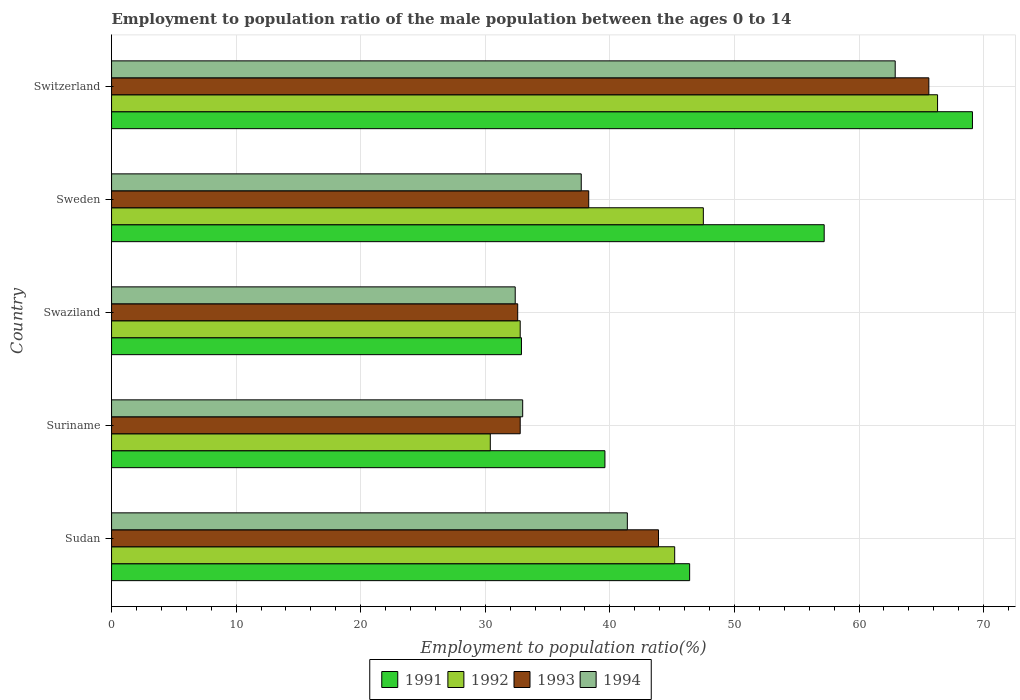How many groups of bars are there?
Keep it short and to the point. 5. Are the number of bars on each tick of the Y-axis equal?
Your response must be concise. Yes. What is the label of the 5th group of bars from the top?
Your answer should be very brief. Sudan. What is the employment to population ratio in 1991 in Swaziland?
Make the answer very short. 32.9. Across all countries, what is the maximum employment to population ratio in 1994?
Your answer should be compact. 62.9. Across all countries, what is the minimum employment to population ratio in 1992?
Your answer should be very brief. 30.4. In which country was the employment to population ratio in 1991 maximum?
Offer a terse response. Switzerland. In which country was the employment to population ratio in 1992 minimum?
Make the answer very short. Suriname. What is the total employment to population ratio in 1993 in the graph?
Offer a very short reply. 213.2. What is the difference between the employment to population ratio in 1994 in Sweden and that in Switzerland?
Give a very brief answer. -25.2. What is the difference between the employment to population ratio in 1993 in Suriname and the employment to population ratio in 1992 in Sweden?
Provide a short and direct response. -14.7. What is the average employment to population ratio in 1993 per country?
Your answer should be very brief. 42.64. What is the difference between the employment to population ratio in 1992 and employment to population ratio in 1991 in Sudan?
Your answer should be very brief. -1.2. What is the ratio of the employment to population ratio in 1991 in Sudan to that in Sweden?
Offer a very short reply. 0.81. Is the employment to population ratio in 1992 in Sudan less than that in Suriname?
Offer a very short reply. No. Is the difference between the employment to population ratio in 1992 in Suriname and Swaziland greater than the difference between the employment to population ratio in 1991 in Suriname and Swaziland?
Your answer should be compact. No. What is the difference between the highest and the second highest employment to population ratio in 1991?
Provide a succinct answer. 11.9. What is the difference between the highest and the lowest employment to population ratio in 1992?
Offer a very short reply. 35.9. Is it the case that in every country, the sum of the employment to population ratio in 1991 and employment to population ratio in 1994 is greater than the sum of employment to population ratio in 1992 and employment to population ratio in 1993?
Ensure brevity in your answer.  No. What does the 4th bar from the top in Swaziland represents?
Offer a very short reply. 1991. Are all the bars in the graph horizontal?
Your response must be concise. Yes. How many countries are there in the graph?
Provide a succinct answer. 5. Are the values on the major ticks of X-axis written in scientific E-notation?
Make the answer very short. No. Does the graph contain any zero values?
Offer a terse response. No. Does the graph contain grids?
Keep it short and to the point. Yes. How many legend labels are there?
Your response must be concise. 4. How are the legend labels stacked?
Offer a terse response. Horizontal. What is the title of the graph?
Your response must be concise. Employment to population ratio of the male population between the ages 0 to 14. Does "2002" appear as one of the legend labels in the graph?
Make the answer very short. No. What is the Employment to population ratio(%) in 1991 in Sudan?
Give a very brief answer. 46.4. What is the Employment to population ratio(%) in 1992 in Sudan?
Offer a very short reply. 45.2. What is the Employment to population ratio(%) of 1993 in Sudan?
Give a very brief answer. 43.9. What is the Employment to population ratio(%) of 1994 in Sudan?
Provide a succinct answer. 41.4. What is the Employment to population ratio(%) in 1991 in Suriname?
Keep it short and to the point. 39.6. What is the Employment to population ratio(%) of 1992 in Suriname?
Your answer should be very brief. 30.4. What is the Employment to population ratio(%) in 1993 in Suriname?
Your response must be concise. 32.8. What is the Employment to population ratio(%) in 1991 in Swaziland?
Give a very brief answer. 32.9. What is the Employment to population ratio(%) in 1992 in Swaziland?
Your answer should be very brief. 32.8. What is the Employment to population ratio(%) of 1993 in Swaziland?
Your response must be concise. 32.6. What is the Employment to population ratio(%) of 1994 in Swaziland?
Give a very brief answer. 32.4. What is the Employment to population ratio(%) in 1991 in Sweden?
Provide a succinct answer. 57.2. What is the Employment to population ratio(%) in 1992 in Sweden?
Your answer should be compact. 47.5. What is the Employment to population ratio(%) in 1993 in Sweden?
Make the answer very short. 38.3. What is the Employment to population ratio(%) in 1994 in Sweden?
Provide a succinct answer. 37.7. What is the Employment to population ratio(%) in 1991 in Switzerland?
Your answer should be compact. 69.1. What is the Employment to population ratio(%) in 1992 in Switzerland?
Ensure brevity in your answer.  66.3. What is the Employment to population ratio(%) of 1993 in Switzerland?
Your answer should be compact. 65.6. What is the Employment to population ratio(%) of 1994 in Switzerland?
Your response must be concise. 62.9. Across all countries, what is the maximum Employment to population ratio(%) in 1991?
Your answer should be very brief. 69.1. Across all countries, what is the maximum Employment to population ratio(%) of 1992?
Your response must be concise. 66.3. Across all countries, what is the maximum Employment to population ratio(%) in 1993?
Provide a succinct answer. 65.6. Across all countries, what is the maximum Employment to population ratio(%) of 1994?
Keep it short and to the point. 62.9. Across all countries, what is the minimum Employment to population ratio(%) of 1991?
Make the answer very short. 32.9. Across all countries, what is the minimum Employment to population ratio(%) of 1992?
Provide a short and direct response. 30.4. Across all countries, what is the minimum Employment to population ratio(%) in 1993?
Your answer should be very brief. 32.6. Across all countries, what is the minimum Employment to population ratio(%) in 1994?
Offer a terse response. 32.4. What is the total Employment to population ratio(%) of 1991 in the graph?
Ensure brevity in your answer.  245.2. What is the total Employment to population ratio(%) in 1992 in the graph?
Provide a succinct answer. 222.2. What is the total Employment to population ratio(%) in 1993 in the graph?
Give a very brief answer. 213.2. What is the total Employment to population ratio(%) in 1994 in the graph?
Offer a very short reply. 207.4. What is the difference between the Employment to population ratio(%) in 1991 in Sudan and that in Sweden?
Ensure brevity in your answer.  -10.8. What is the difference between the Employment to population ratio(%) in 1991 in Sudan and that in Switzerland?
Provide a succinct answer. -22.7. What is the difference between the Employment to population ratio(%) in 1992 in Sudan and that in Switzerland?
Your answer should be compact. -21.1. What is the difference between the Employment to population ratio(%) in 1993 in Sudan and that in Switzerland?
Ensure brevity in your answer.  -21.7. What is the difference between the Employment to population ratio(%) in 1994 in Sudan and that in Switzerland?
Offer a terse response. -21.5. What is the difference between the Employment to population ratio(%) of 1992 in Suriname and that in Swaziland?
Offer a very short reply. -2.4. What is the difference between the Employment to population ratio(%) in 1993 in Suriname and that in Swaziland?
Your answer should be very brief. 0.2. What is the difference between the Employment to population ratio(%) of 1991 in Suriname and that in Sweden?
Offer a terse response. -17.6. What is the difference between the Employment to population ratio(%) in 1992 in Suriname and that in Sweden?
Provide a succinct answer. -17.1. What is the difference between the Employment to population ratio(%) in 1993 in Suriname and that in Sweden?
Your response must be concise. -5.5. What is the difference between the Employment to population ratio(%) of 1994 in Suriname and that in Sweden?
Ensure brevity in your answer.  -4.7. What is the difference between the Employment to population ratio(%) in 1991 in Suriname and that in Switzerland?
Provide a short and direct response. -29.5. What is the difference between the Employment to population ratio(%) in 1992 in Suriname and that in Switzerland?
Ensure brevity in your answer.  -35.9. What is the difference between the Employment to population ratio(%) in 1993 in Suriname and that in Switzerland?
Offer a very short reply. -32.8. What is the difference between the Employment to population ratio(%) of 1994 in Suriname and that in Switzerland?
Offer a very short reply. -29.9. What is the difference between the Employment to population ratio(%) in 1991 in Swaziland and that in Sweden?
Your answer should be very brief. -24.3. What is the difference between the Employment to population ratio(%) in 1992 in Swaziland and that in Sweden?
Provide a short and direct response. -14.7. What is the difference between the Employment to population ratio(%) in 1993 in Swaziland and that in Sweden?
Your answer should be compact. -5.7. What is the difference between the Employment to population ratio(%) in 1991 in Swaziland and that in Switzerland?
Make the answer very short. -36.2. What is the difference between the Employment to population ratio(%) in 1992 in Swaziland and that in Switzerland?
Make the answer very short. -33.5. What is the difference between the Employment to population ratio(%) in 1993 in Swaziland and that in Switzerland?
Offer a very short reply. -33. What is the difference between the Employment to population ratio(%) of 1994 in Swaziland and that in Switzerland?
Offer a terse response. -30.5. What is the difference between the Employment to population ratio(%) of 1991 in Sweden and that in Switzerland?
Offer a very short reply. -11.9. What is the difference between the Employment to population ratio(%) in 1992 in Sweden and that in Switzerland?
Your response must be concise. -18.8. What is the difference between the Employment to population ratio(%) of 1993 in Sweden and that in Switzerland?
Provide a short and direct response. -27.3. What is the difference between the Employment to population ratio(%) in 1994 in Sweden and that in Switzerland?
Your response must be concise. -25.2. What is the difference between the Employment to population ratio(%) in 1991 in Sudan and the Employment to population ratio(%) in 1992 in Suriname?
Your answer should be very brief. 16. What is the difference between the Employment to population ratio(%) of 1991 in Sudan and the Employment to population ratio(%) of 1993 in Suriname?
Make the answer very short. 13.6. What is the difference between the Employment to population ratio(%) in 1992 in Sudan and the Employment to population ratio(%) in 1993 in Suriname?
Your answer should be compact. 12.4. What is the difference between the Employment to population ratio(%) in 1992 in Sudan and the Employment to population ratio(%) in 1994 in Suriname?
Offer a terse response. 12.2. What is the difference between the Employment to population ratio(%) of 1993 in Sudan and the Employment to population ratio(%) of 1994 in Suriname?
Provide a succinct answer. 10.9. What is the difference between the Employment to population ratio(%) in 1991 in Sudan and the Employment to population ratio(%) in 1993 in Swaziland?
Offer a very short reply. 13.8. What is the difference between the Employment to population ratio(%) in 1991 in Sudan and the Employment to population ratio(%) in 1992 in Sweden?
Give a very brief answer. -1.1. What is the difference between the Employment to population ratio(%) in 1991 in Sudan and the Employment to population ratio(%) in 1994 in Sweden?
Provide a short and direct response. 8.7. What is the difference between the Employment to population ratio(%) in 1992 in Sudan and the Employment to population ratio(%) in 1994 in Sweden?
Provide a succinct answer. 7.5. What is the difference between the Employment to population ratio(%) of 1993 in Sudan and the Employment to population ratio(%) of 1994 in Sweden?
Offer a very short reply. 6.2. What is the difference between the Employment to population ratio(%) in 1991 in Sudan and the Employment to population ratio(%) in 1992 in Switzerland?
Provide a succinct answer. -19.9. What is the difference between the Employment to population ratio(%) in 1991 in Sudan and the Employment to population ratio(%) in 1993 in Switzerland?
Your answer should be compact. -19.2. What is the difference between the Employment to population ratio(%) in 1991 in Sudan and the Employment to population ratio(%) in 1994 in Switzerland?
Give a very brief answer. -16.5. What is the difference between the Employment to population ratio(%) in 1992 in Sudan and the Employment to population ratio(%) in 1993 in Switzerland?
Your answer should be compact. -20.4. What is the difference between the Employment to population ratio(%) in 1992 in Sudan and the Employment to population ratio(%) in 1994 in Switzerland?
Provide a short and direct response. -17.7. What is the difference between the Employment to population ratio(%) of 1993 in Sudan and the Employment to population ratio(%) of 1994 in Switzerland?
Make the answer very short. -19. What is the difference between the Employment to population ratio(%) of 1991 in Suriname and the Employment to population ratio(%) of 1992 in Swaziland?
Your answer should be compact. 6.8. What is the difference between the Employment to population ratio(%) in 1991 in Suriname and the Employment to population ratio(%) in 1993 in Swaziland?
Offer a terse response. 7. What is the difference between the Employment to population ratio(%) in 1992 in Suriname and the Employment to population ratio(%) in 1993 in Swaziland?
Your answer should be very brief. -2.2. What is the difference between the Employment to population ratio(%) of 1991 in Suriname and the Employment to population ratio(%) of 1994 in Sweden?
Offer a very short reply. 1.9. What is the difference between the Employment to population ratio(%) in 1992 in Suriname and the Employment to population ratio(%) in 1993 in Sweden?
Provide a short and direct response. -7.9. What is the difference between the Employment to population ratio(%) in 1992 in Suriname and the Employment to population ratio(%) in 1994 in Sweden?
Provide a succinct answer. -7.3. What is the difference between the Employment to population ratio(%) in 1993 in Suriname and the Employment to population ratio(%) in 1994 in Sweden?
Give a very brief answer. -4.9. What is the difference between the Employment to population ratio(%) of 1991 in Suriname and the Employment to population ratio(%) of 1992 in Switzerland?
Make the answer very short. -26.7. What is the difference between the Employment to population ratio(%) in 1991 in Suriname and the Employment to population ratio(%) in 1994 in Switzerland?
Your answer should be compact. -23.3. What is the difference between the Employment to population ratio(%) of 1992 in Suriname and the Employment to population ratio(%) of 1993 in Switzerland?
Ensure brevity in your answer.  -35.2. What is the difference between the Employment to population ratio(%) of 1992 in Suriname and the Employment to population ratio(%) of 1994 in Switzerland?
Make the answer very short. -32.5. What is the difference between the Employment to population ratio(%) of 1993 in Suriname and the Employment to population ratio(%) of 1994 in Switzerland?
Offer a very short reply. -30.1. What is the difference between the Employment to population ratio(%) of 1991 in Swaziland and the Employment to population ratio(%) of 1992 in Sweden?
Provide a short and direct response. -14.6. What is the difference between the Employment to population ratio(%) in 1991 in Swaziland and the Employment to population ratio(%) in 1994 in Sweden?
Offer a very short reply. -4.8. What is the difference between the Employment to population ratio(%) in 1992 in Swaziland and the Employment to population ratio(%) in 1993 in Sweden?
Your answer should be very brief. -5.5. What is the difference between the Employment to population ratio(%) of 1993 in Swaziland and the Employment to population ratio(%) of 1994 in Sweden?
Provide a short and direct response. -5.1. What is the difference between the Employment to population ratio(%) of 1991 in Swaziland and the Employment to population ratio(%) of 1992 in Switzerland?
Provide a succinct answer. -33.4. What is the difference between the Employment to population ratio(%) in 1991 in Swaziland and the Employment to population ratio(%) in 1993 in Switzerland?
Your response must be concise. -32.7. What is the difference between the Employment to population ratio(%) of 1992 in Swaziland and the Employment to population ratio(%) of 1993 in Switzerland?
Keep it short and to the point. -32.8. What is the difference between the Employment to population ratio(%) of 1992 in Swaziland and the Employment to population ratio(%) of 1994 in Switzerland?
Ensure brevity in your answer.  -30.1. What is the difference between the Employment to population ratio(%) of 1993 in Swaziland and the Employment to population ratio(%) of 1994 in Switzerland?
Offer a terse response. -30.3. What is the difference between the Employment to population ratio(%) in 1991 in Sweden and the Employment to population ratio(%) in 1992 in Switzerland?
Your answer should be very brief. -9.1. What is the difference between the Employment to population ratio(%) of 1992 in Sweden and the Employment to population ratio(%) of 1993 in Switzerland?
Provide a short and direct response. -18.1. What is the difference between the Employment to population ratio(%) of 1992 in Sweden and the Employment to population ratio(%) of 1994 in Switzerland?
Your answer should be very brief. -15.4. What is the difference between the Employment to population ratio(%) in 1993 in Sweden and the Employment to population ratio(%) in 1994 in Switzerland?
Ensure brevity in your answer.  -24.6. What is the average Employment to population ratio(%) in 1991 per country?
Make the answer very short. 49.04. What is the average Employment to population ratio(%) of 1992 per country?
Your response must be concise. 44.44. What is the average Employment to population ratio(%) of 1993 per country?
Your answer should be very brief. 42.64. What is the average Employment to population ratio(%) in 1994 per country?
Make the answer very short. 41.48. What is the difference between the Employment to population ratio(%) in 1991 and Employment to population ratio(%) in 1992 in Sudan?
Provide a succinct answer. 1.2. What is the difference between the Employment to population ratio(%) in 1991 and Employment to population ratio(%) in 1993 in Sudan?
Keep it short and to the point. 2.5. What is the difference between the Employment to population ratio(%) of 1992 and Employment to population ratio(%) of 1994 in Sudan?
Give a very brief answer. 3.8. What is the difference between the Employment to population ratio(%) of 1993 and Employment to population ratio(%) of 1994 in Sudan?
Give a very brief answer. 2.5. What is the difference between the Employment to population ratio(%) in 1991 and Employment to population ratio(%) in 1992 in Suriname?
Your answer should be very brief. 9.2. What is the difference between the Employment to population ratio(%) of 1991 and Employment to population ratio(%) of 1993 in Suriname?
Provide a short and direct response. 6.8. What is the difference between the Employment to population ratio(%) of 1991 and Employment to population ratio(%) of 1994 in Suriname?
Your answer should be very brief. 6.6. What is the difference between the Employment to population ratio(%) in 1992 and Employment to population ratio(%) in 1993 in Suriname?
Give a very brief answer. -2.4. What is the difference between the Employment to population ratio(%) of 1992 and Employment to population ratio(%) of 1994 in Suriname?
Offer a terse response. -2.6. What is the difference between the Employment to population ratio(%) of 1991 and Employment to population ratio(%) of 1993 in Swaziland?
Give a very brief answer. 0.3. What is the difference between the Employment to population ratio(%) of 1992 and Employment to population ratio(%) of 1994 in Swaziland?
Your answer should be compact. 0.4. What is the difference between the Employment to population ratio(%) of 1991 and Employment to population ratio(%) of 1992 in Sweden?
Your answer should be compact. 9.7. What is the difference between the Employment to population ratio(%) in 1993 and Employment to population ratio(%) in 1994 in Switzerland?
Your answer should be very brief. 2.7. What is the ratio of the Employment to population ratio(%) in 1991 in Sudan to that in Suriname?
Your response must be concise. 1.17. What is the ratio of the Employment to population ratio(%) in 1992 in Sudan to that in Suriname?
Keep it short and to the point. 1.49. What is the ratio of the Employment to population ratio(%) of 1993 in Sudan to that in Suriname?
Provide a succinct answer. 1.34. What is the ratio of the Employment to population ratio(%) of 1994 in Sudan to that in Suriname?
Offer a very short reply. 1.25. What is the ratio of the Employment to population ratio(%) in 1991 in Sudan to that in Swaziland?
Give a very brief answer. 1.41. What is the ratio of the Employment to population ratio(%) in 1992 in Sudan to that in Swaziland?
Ensure brevity in your answer.  1.38. What is the ratio of the Employment to population ratio(%) of 1993 in Sudan to that in Swaziland?
Offer a very short reply. 1.35. What is the ratio of the Employment to population ratio(%) of 1994 in Sudan to that in Swaziland?
Your answer should be compact. 1.28. What is the ratio of the Employment to population ratio(%) of 1991 in Sudan to that in Sweden?
Provide a short and direct response. 0.81. What is the ratio of the Employment to population ratio(%) of 1992 in Sudan to that in Sweden?
Provide a short and direct response. 0.95. What is the ratio of the Employment to population ratio(%) of 1993 in Sudan to that in Sweden?
Provide a short and direct response. 1.15. What is the ratio of the Employment to population ratio(%) in 1994 in Sudan to that in Sweden?
Your answer should be very brief. 1.1. What is the ratio of the Employment to population ratio(%) of 1991 in Sudan to that in Switzerland?
Your answer should be very brief. 0.67. What is the ratio of the Employment to population ratio(%) in 1992 in Sudan to that in Switzerland?
Give a very brief answer. 0.68. What is the ratio of the Employment to population ratio(%) in 1993 in Sudan to that in Switzerland?
Keep it short and to the point. 0.67. What is the ratio of the Employment to population ratio(%) in 1994 in Sudan to that in Switzerland?
Keep it short and to the point. 0.66. What is the ratio of the Employment to population ratio(%) in 1991 in Suriname to that in Swaziland?
Offer a very short reply. 1.2. What is the ratio of the Employment to population ratio(%) in 1992 in Suriname to that in Swaziland?
Your answer should be compact. 0.93. What is the ratio of the Employment to population ratio(%) in 1993 in Suriname to that in Swaziland?
Offer a terse response. 1.01. What is the ratio of the Employment to population ratio(%) of 1994 in Suriname to that in Swaziland?
Offer a very short reply. 1.02. What is the ratio of the Employment to population ratio(%) of 1991 in Suriname to that in Sweden?
Provide a succinct answer. 0.69. What is the ratio of the Employment to population ratio(%) in 1992 in Suriname to that in Sweden?
Provide a succinct answer. 0.64. What is the ratio of the Employment to population ratio(%) of 1993 in Suriname to that in Sweden?
Ensure brevity in your answer.  0.86. What is the ratio of the Employment to population ratio(%) in 1994 in Suriname to that in Sweden?
Give a very brief answer. 0.88. What is the ratio of the Employment to population ratio(%) of 1991 in Suriname to that in Switzerland?
Offer a terse response. 0.57. What is the ratio of the Employment to population ratio(%) in 1992 in Suriname to that in Switzerland?
Provide a short and direct response. 0.46. What is the ratio of the Employment to population ratio(%) in 1993 in Suriname to that in Switzerland?
Your answer should be compact. 0.5. What is the ratio of the Employment to population ratio(%) of 1994 in Suriname to that in Switzerland?
Provide a short and direct response. 0.52. What is the ratio of the Employment to population ratio(%) in 1991 in Swaziland to that in Sweden?
Ensure brevity in your answer.  0.58. What is the ratio of the Employment to population ratio(%) of 1992 in Swaziland to that in Sweden?
Your answer should be compact. 0.69. What is the ratio of the Employment to population ratio(%) of 1993 in Swaziland to that in Sweden?
Your response must be concise. 0.85. What is the ratio of the Employment to population ratio(%) of 1994 in Swaziland to that in Sweden?
Offer a terse response. 0.86. What is the ratio of the Employment to population ratio(%) in 1991 in Swaziland to that in Switzerland?
Offer a terse response. 0.48. What is the ratio of the Employment to population ratio(%) of 1992 in Swaziland to that in Switzerland?
Give a very brief answer. 0.49. What is the ratio of the Employment to population ratio(%) of 1993 in Swaziland to that in Switzerland?
Offer a very short reply. 0.5. What is the ratio of the Employment to population ratio(%) in 1994 in Swaziland to that in Switzerland?
Your answer should be very brief. 0.52. What is the ratio of the Employment to population ratio(%) of 1991 in Sweden to that in Switzerland?
Your response must be concise. 0.83. What is the ratio of the Employment to population ratio(%) in 1992 in Sweden to that in Switzerland?
Provide a succinct answer. 0.72. What is the ratio of the Employment to population ratio(%) of 1993 in Sweden to that in Switzerland?
Make the answer very short. 0.58. What is the ratio of the Employment to population ratio(%) of 1994 in Sweden to that in Switzerland?
Provide a short and direct response. 0.6. What is the difference between the highest and the second highest Employment to population ratio(%) in 1991?
Keep it short and to the point. 11.9. What is the difference between the highest and the second highest Employment to population ratio(%) of 1993?
Provide a succinct answer. 21.7. What is the difference between the highest and the lowest Employment to population ratio(%) of 1991?
Make the answer very short. 36.2. What is the difference between the highest and the lowest Employment to population ratio(%) of 1992?
Ensure brevity in your answer.  35.9. What is the difference between the highest and the lowest Employment to population ratio(%) in 1994?
Ensure brevity in your answer.  30.5. 